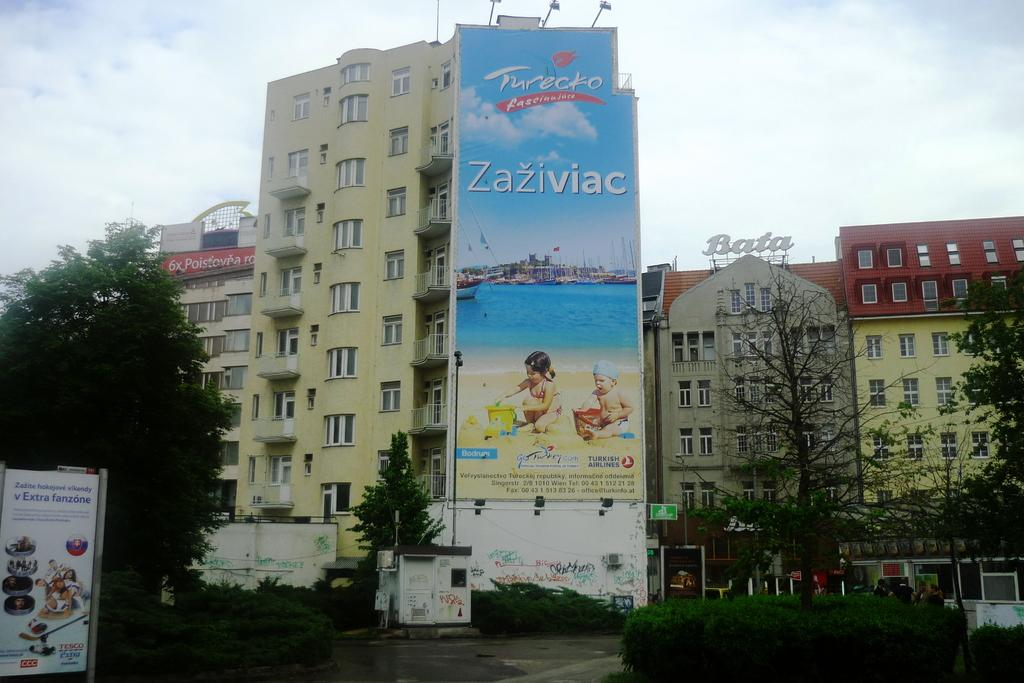<image>
Relay a brief, clear account of the picture shown. big buidling with a sign on the outside called zaziviac 